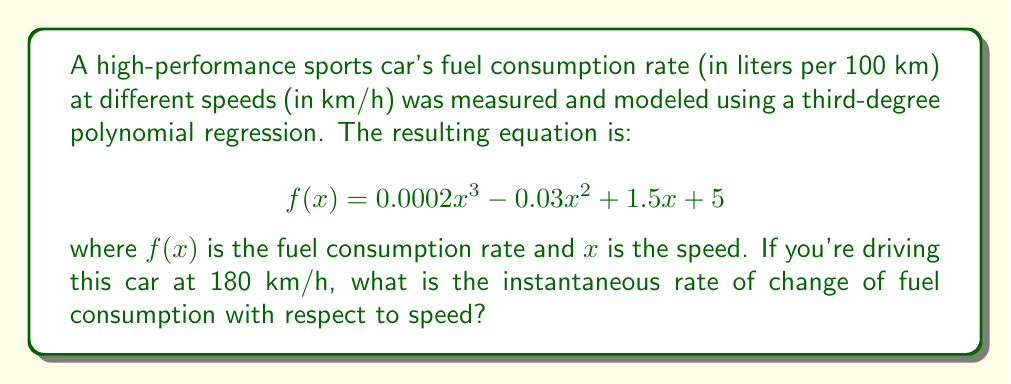What is the answer to this math problem? To find the instantaneous rate of change of fuel consumption with respect to speed at 180 km/h, we need to calculate the derivative of the given function $f(x)$ and then evaluate it at $x = 180$.

Step 1: Calculate the derivative of $f(x)$.
$$f(x) = 0.0002x^3 - 0.03x^2 + 1.5x + 5$$
$$f'(x) = 0.0006x^2 - 0.06x + 1.5$$

Step 2: Evaluate $f'(x)$ at $x = 180$.
$$f'(180) = 0.0006(180)^2 - 0.06(180) + 1.5$$
$$f'(180) = 0.0006(32400) - 10.8 + 1.5$$
$$f'(180) = 19.44 - 10.8 + 1.5$$
$$f'(180) = 10.14$$

The result, 10.14, represents the instantaneous rate of change of fuel consumption with respect to speed at 180 km/h. This means that at 180 km/h, the fuel consumption is increasing at a rate of 10.14 liters per 100 km for each 1 km/h increase in speed.
Answer: 10.14 L/(100 km·km/h) 